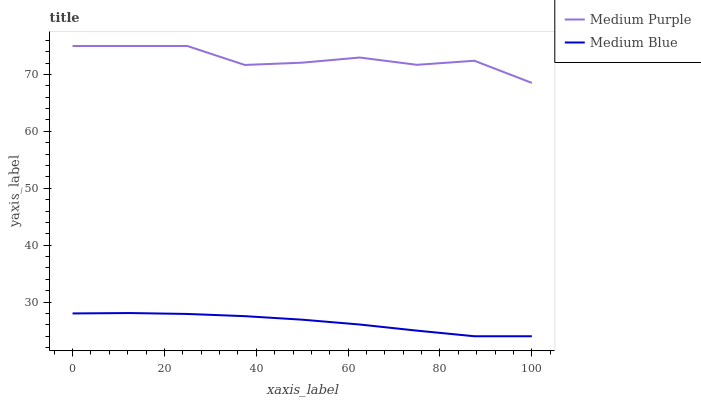Does Medium Blue have the minimum area under the curve?
Answer yes or no. Yes. Does Medium Purple have the maximum area under the curve?
Answer yes or no. Yes. Does Medium Blue have the maximum area under the curve?
Answer yes or no. No. Is Medium Blue the smoothest?
Answer yes or no. Yes. Is Medium Purple the roughest?
Answer yes or no. Yes. Is Medium Blue the roughest?
Answer yes or no. No. Does Medium Purple have the highest value?
Answer yes or no. Yes. Does Medium Blue have the highest value?
Answer yes or no. No. Is Medium Blue less than Medium Purple?
Answer yes or no. Yes. Is Medium Purple greater than Medium Blue?
Answer yes or no. Yes. Does Medium Blue intersect Medium Purple?
Answer yes or no. No. 